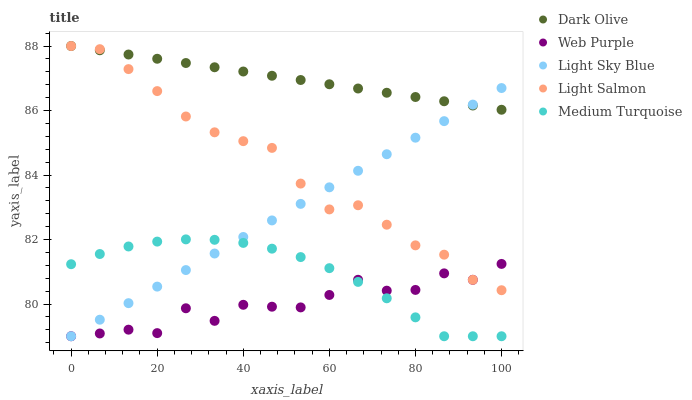Does Web Purple have the minimum area under the curve?
Answer yes or no. Yes. Does Dark Olive have the maximum area under the curve?
Answer yes or no. Yes. Does Light Salmon have the minimum area under the curve?
Answer yes or no. No. Does Light Salmon have the maximum area under the curve?
Answer yes or no. No. Is Light Sky Blue the smoothest?
Answer yes or no. Yes. Is Web Purple the roughest?
Answer yes or no. Yes. Is Dark Olive the smoothest?
Answer yes or no. No. Is Dark Olive the roughest?
Answer yes or no. No. Does Web Purple have the lowest value?
Answer yes or no. Yes. Does Light Salmon have the lowest value?
Answer yes or no. No. Does Light Salmon have the highest value?
Answer yes or no. Yes. Does Light Sky Blue have the highest value?
Answer yes or no. No. Is Medium Turquoise less than Dark Olive?
Answer yes or no. Yes. Is Dark Olive greater than Medium Turquoise?
Answer yes or no. Yes. Does Light Salmon intersect Dark Olive?
Answer yes or no. Yes. Is Light Salmon less than Dark Olive?
Answer yes or no. No. Is Light Salmon greater than Dark Olive?
Answer yes or no. No. Does Medium Turquoise intersect Dark Olive?
Answer yes or no. No. 